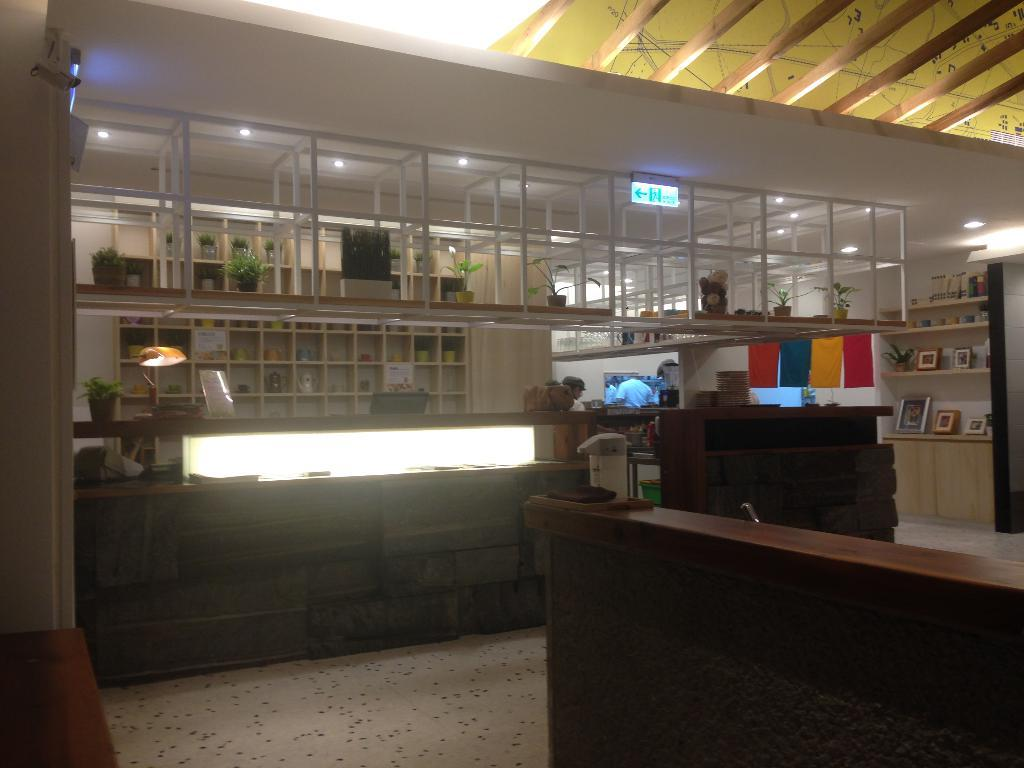What type of surface can be seen in the image? There is a platform and a floor visible in the image. What material is one of the objects made of? There is a wooden object in the image. What can be used to provide illumination in the image? There are lights in the image. Are there any living organisms present in the image? Yes, there are people in the image. What type of vegetation is present in the image? There are house plants in the image. What type of decorative items can be seen in the image? There are frames in the image. What type of storage is present in the image? There are objects on racks in the image. What type of display is present in the image? There are objects on walls in the image. What type of board is present in the image? There is a board in the image. What type of advice can be seen written on the potato in the image? There is no potato present in the image, so no advice can be seen on it. 